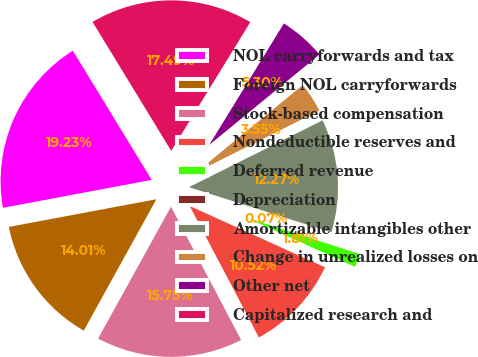Convert chart to OTSL. <chart><loc_0><loc_0><loc_500><loc_500><pie_chart><fcel>NOL carryforwards and tax<fcel>Foreign NOL carryforwards<fcel>Stock-based compensation<fcel>Nondeductible reserves and<fcel>Deferred revenue<fcel>Depreciation<fcel>Amortizable intangibles other<fcel>Change in unrealized losses on<fcel>Other net<fcel>Capitalized research and<nl><fcel>19.23%<fcel>14.01%<fcel>15.75%<fcel>10.52%<fcel>1.81%<fcel>0.07%<fcel>12.27%<fcel>3.55%<fcel>5.3%<fcel>17.49%<nl></chart> 